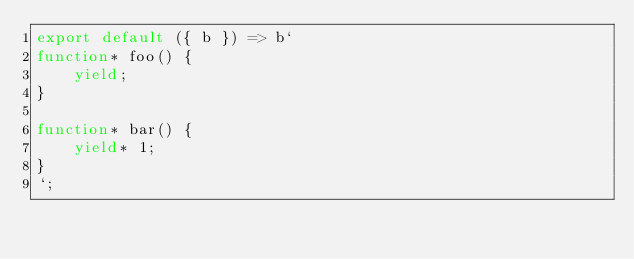<code> <loc_0><loc_0><loc_500><loc_500><_JavaScript_>export default ({ b }) => b`
function* foo() {
	yield;
}

function* bar() {
	yield* 1;
}
`;</code> 